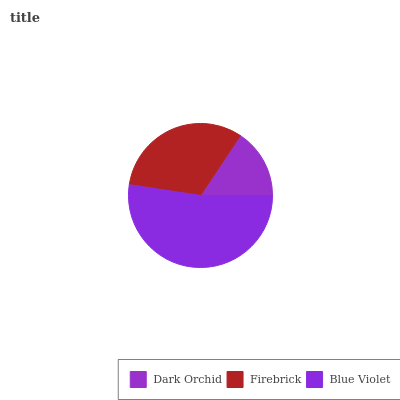Is Dark Orchid the minimum?
Answer yes or no. Yes. Is Blue Violet the maximum?
Answer yes or no. Yes. Is Firebrick the minimum?
Answer yes or no. No. Is Firebrick the maximum?
Answer yes or no. No. Is Firebrick greater than Dark Orchid?
Answer yes or no. Yes. Is Dark Orchid less than Firebrick?
Answer yes or no. Yes. Is Dark Orchid greater than Firebrick?
Answer yes or no. No. Is Firebrick less than Dark Orchid?
Answer yes or no. No. Is Firebrick the high median?
Answer yes or no. Yes. Is Firebrick the low median?
Answer yes or no. Yes. Is Dark Orchid the high median?
Answer yes or no. No. Is Blue Violet the low median?
Answer yes or no. No. 